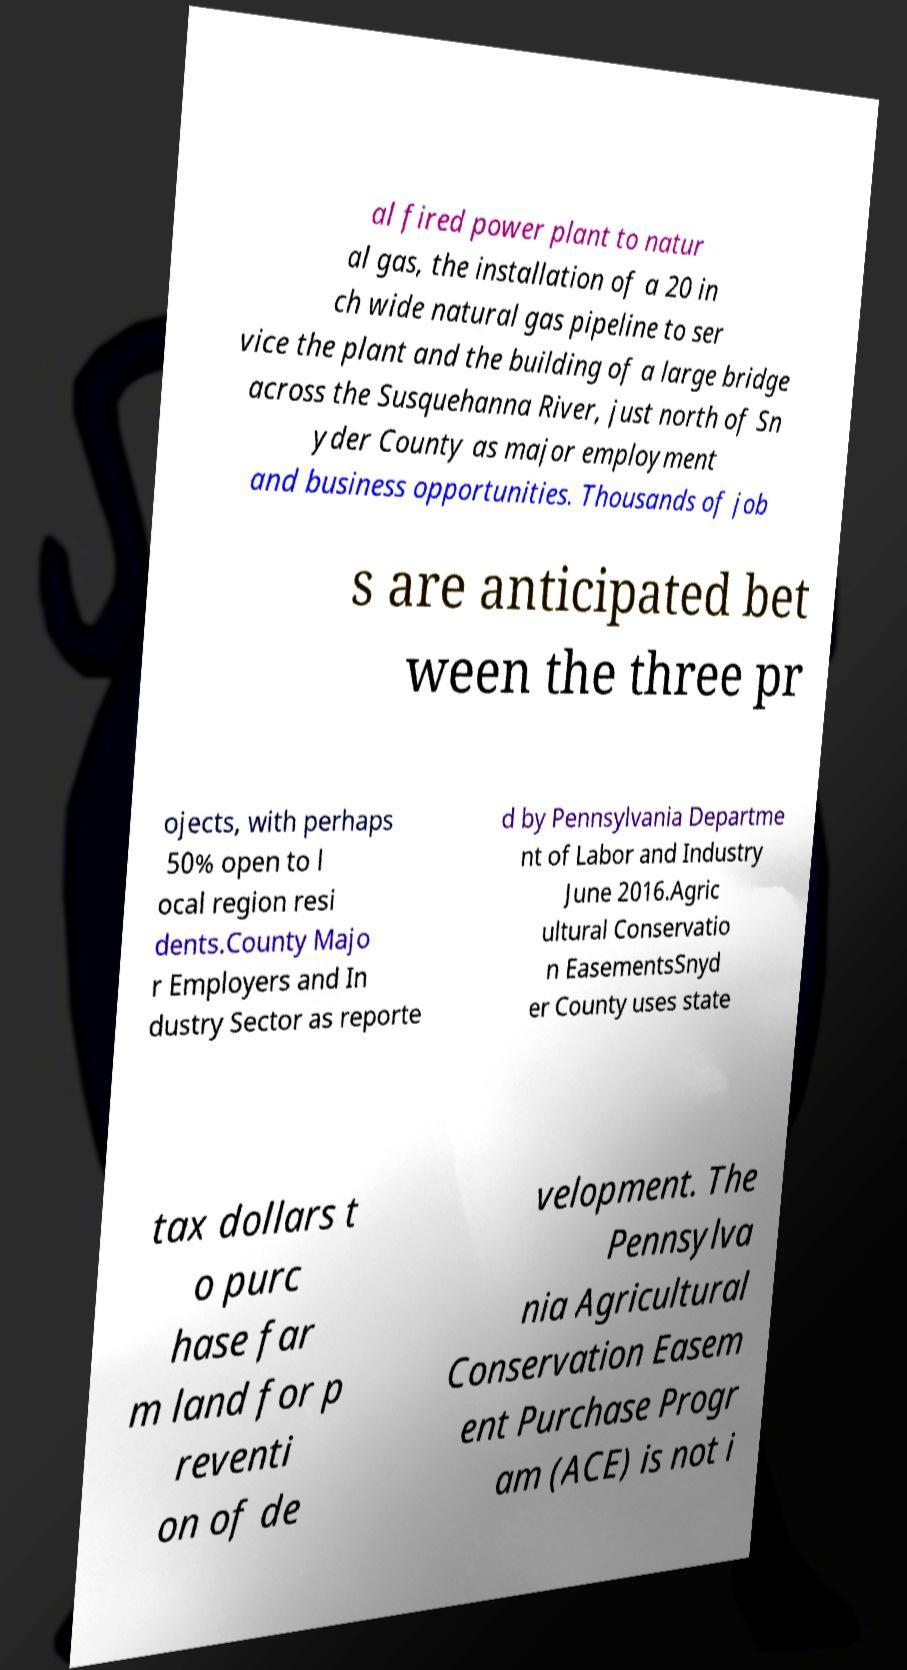Could you extract and type out the text from this image? al fired power plant to natur al gas, the installation of a 20 in ch wide natural gas pipeline to ser vice the plant and the building of a large bridge across the Susquehanna River, just north of Sn yder County as major employment and business opportunities. Thousands of job s are anticipated bet ween the three pr ojects, with perhaps 50% open to l ocal region resi dents.County Majo r Employers and In dustry Sector as reporte d by Pennsylvania Departme nt of Labor and Industry June 2016.Agric ultural Conservatio n EasementsSnyd er County uses state tax dollars t o purc hase far m land for p reventi on of de velopment. The Pennsylva nia Agricultural Conservation Easem ent Purchase Progr am (ACE) is not i 